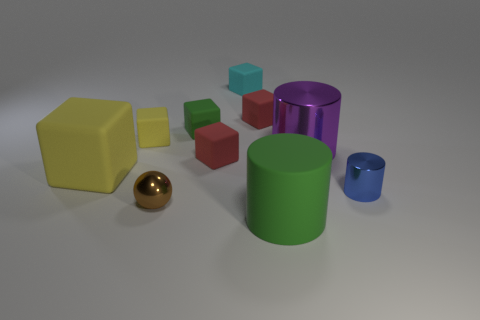Subtract 1 cubes. How many cubes are left? 5 Subtract all yellow cubes. How many cubes are left? 4 Subtract all yellow blocks. How many blocks are left? 4 Subtract all purple cubes. Subtract all brown spheres. How many cubes are left? 6 Subtract all cylinders. How many objects are left? 7 Subtract all small green objects. Subtract all small cyan rubber blocks. How many objects are left? 8 Add 3 brown metal spheres. How many brown metal spheres are left? 4 Add 2 blue metal things. How many blue metal things exist? 3 Subtract 1 yellow blocks. How many objects are left? 9 